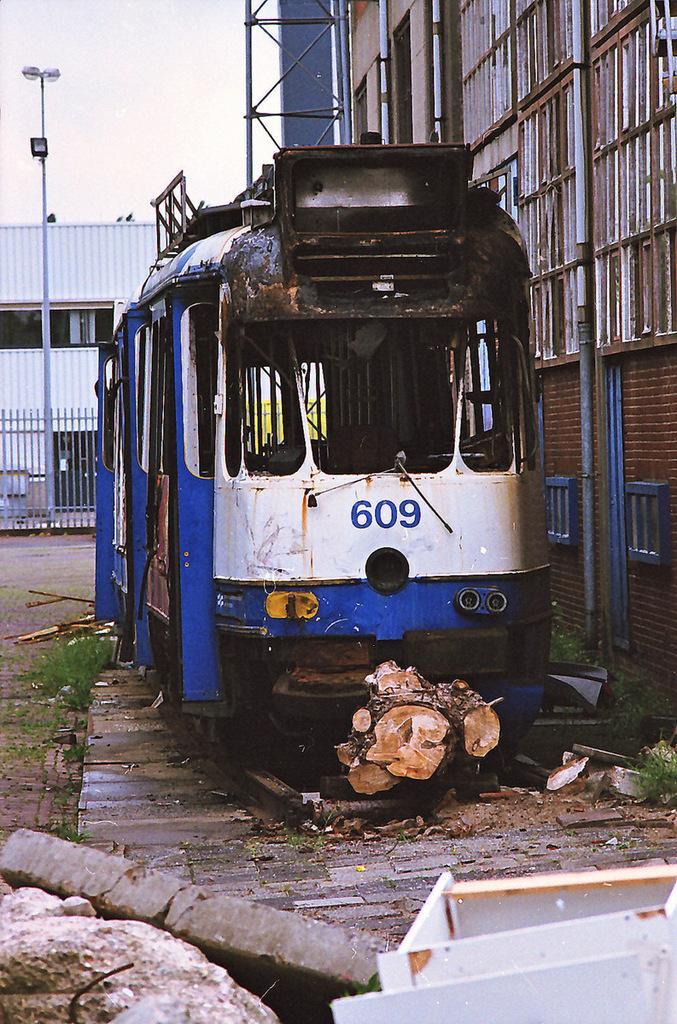Can you describe this image briefly? In this image I can see the vehicle which is in white and blue color. It is to the side of the building. In the front I can see the rock and white color box. In the back I can see the railing, shirt, light pole and the sky. 